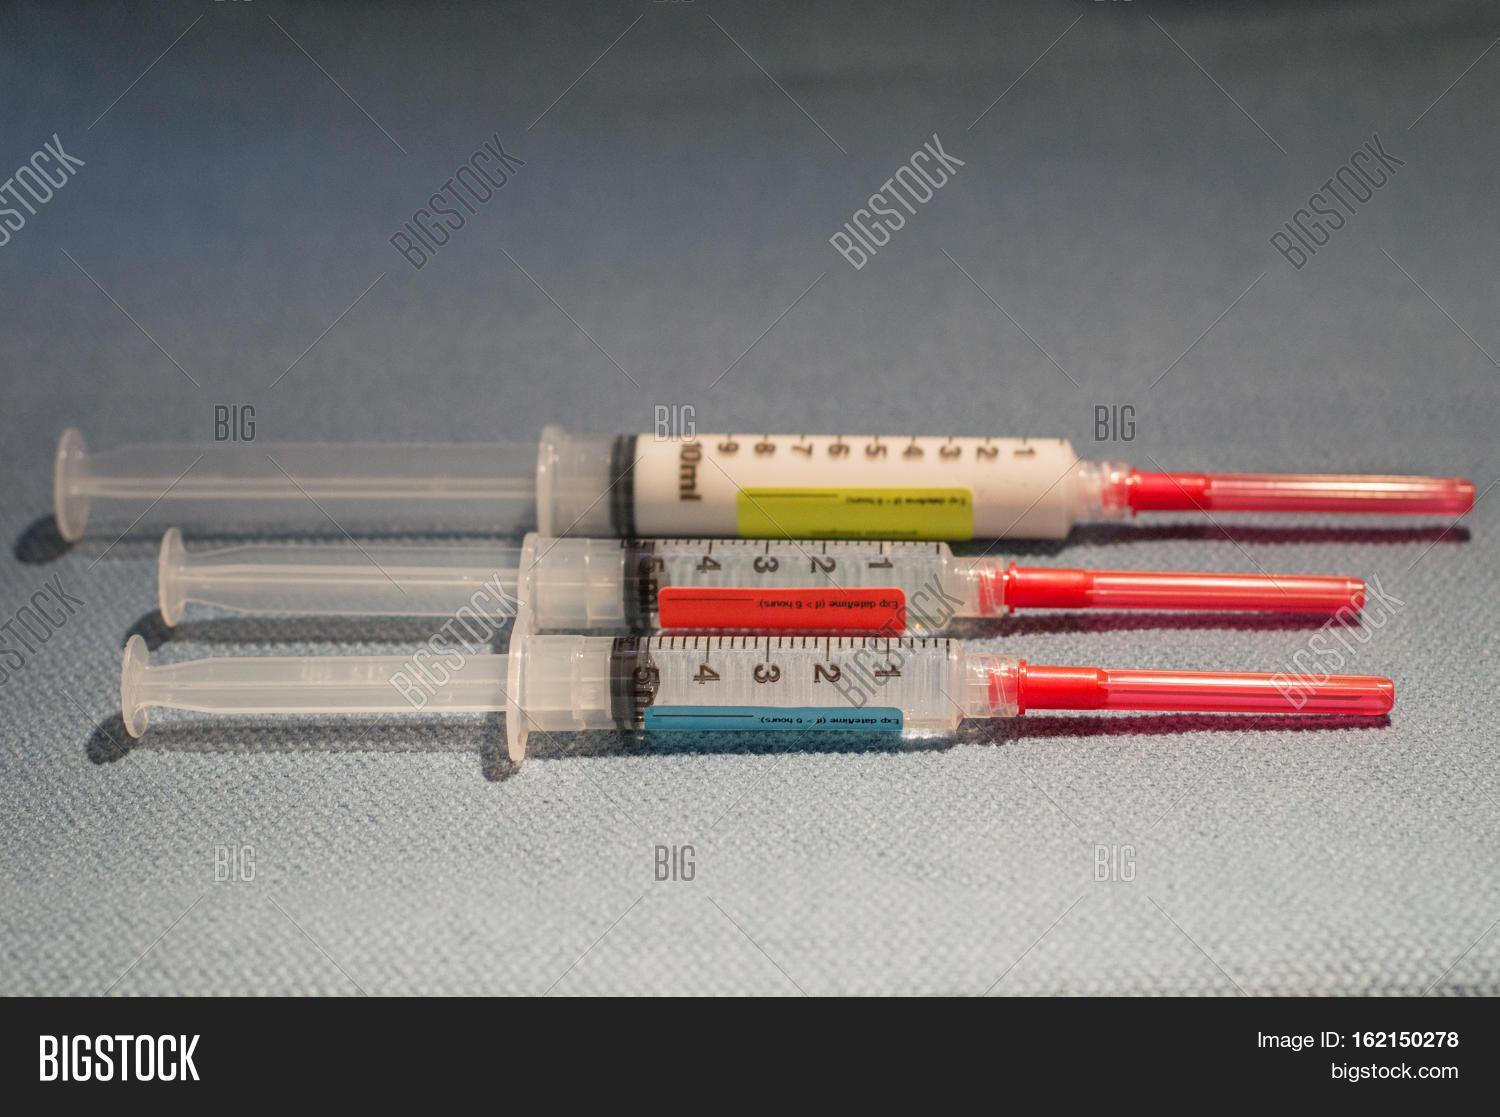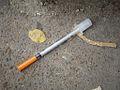The first image is the image on the left, the second image is the image on the right. Examine the images to the left and right. Is the description "There are two more syringes on the right side" accurate? Answer yes or no. No. The first image is the image on the left, the second image is the image on the right. Assess this claim about the two images: "There are four unbagged syringes, one in one image and three in the other.". Correct or not? Answer yes or no. Yes. 